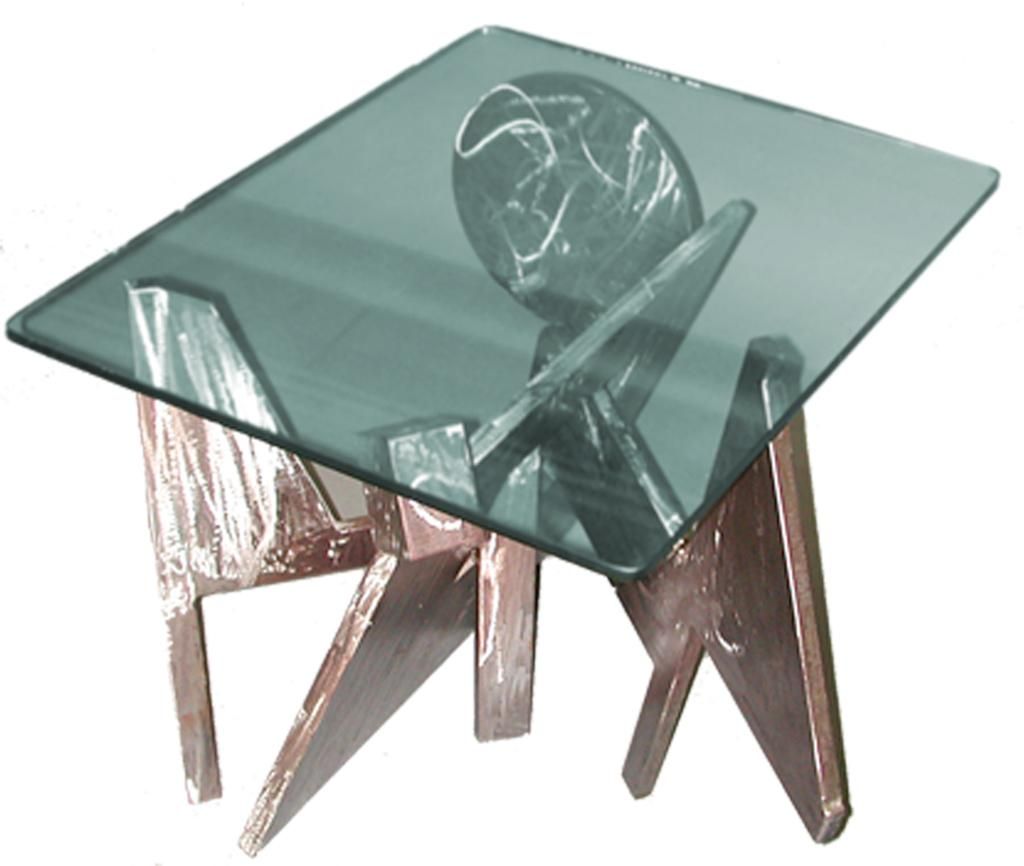What type of table is in the center of the image? There is a glass table in the center of the image. Can you describe the location of the table in the image? The glass table is in the center of the image. How many potatoes are visible on the ground beneath the glass table in the image? There are no potatoes visible in the image, and the ground is not mentioned in the provided facts. 